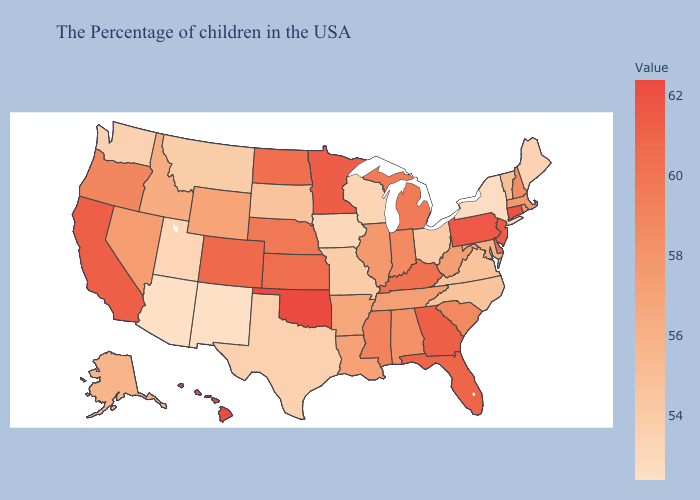Does Pennsylvania have the highest value in the USA?
Write a very short answer. No. Among the states that border Michigan , does Wisconsin have the lowest value?
Concise answer only. Yes. Does South Carolina have a lower value than Utah?
Be succinct. No. Does Missouri have a lower value than New York?
Quick response, please. No. 